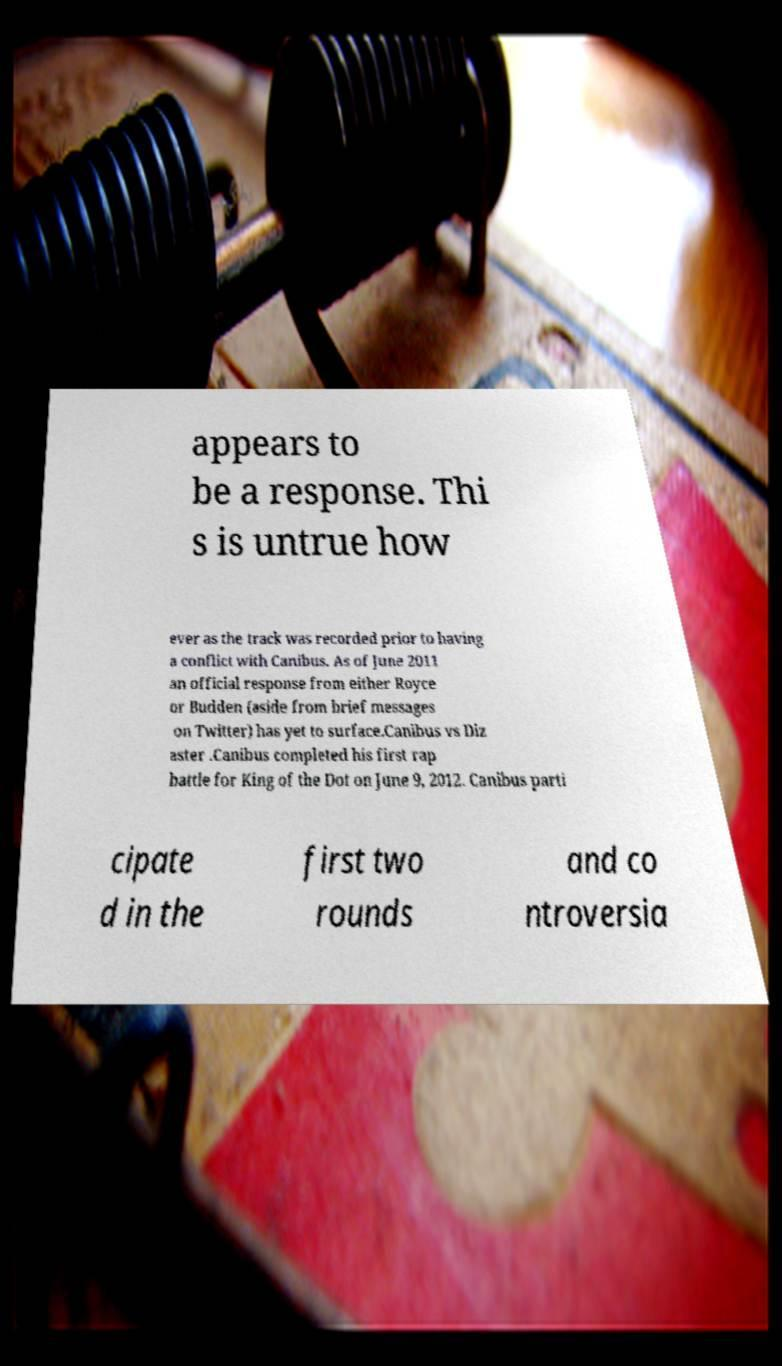Could you extract and type out the text from this image? appears to be a response. Thi s is untrue how ever as the track was recorded prior to having a conflict with Canibus. As of June 2011 an official response from either Royce or Budden (aside from brief messages on Twitter) has yet to surface.Canibus vs Diz aster .Canibus completed his first rap battle for King of the Dot on June 9, 2012. Canibus parti cipate d in the first two rounds and co ntroversia 